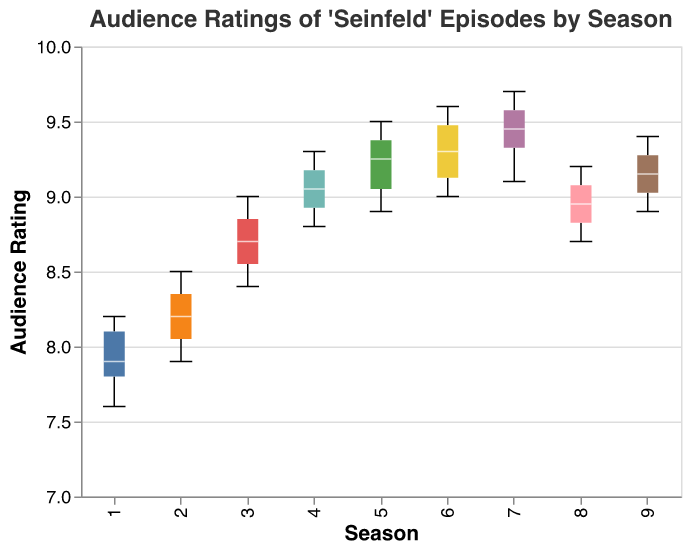What is the title of the plot? The title of the plot is located at the top of the figure and provides a summary of what the plot represents.
Answer: "Audience Ratings of 'Seinfeld' Episodes by Season" How many seasons of 'Seinfeld' are represented in the plot? Counting the distinct groups along the x-axis, we can see the different seasons represented.
Answer: 9 Which season has the highest median audience rating? The median can be identified by examining the line inside each box; the season with the highest median line is Season 7.
Answer: Season 7 What is the range of ratings for Season 1? The range can be determined by looking at the distance between the minimum and maximum ticks inside the box plot for Season 1. The range is from 7.6 to 8.2.
Answer: 0.6 Is there a season with no overlap in ratings with Season 7? By examining the notches in the box plot, which indicate the confidence intervals for the medians, we can see if there is any overlap. Season 1 does not overlap with Season 7.
Answer: Season 1 What is the median rating for Season 5? The median is marked by the line inside the box for Season 5, which is around 9.3.
Answer: 9.3 Which season has the widest interquartile range (IQR) for audience ratings? The IQR is the range between the first quartile (bottom of the box) and the third quartile (top of the box); the season with the largest box is Season 1.
Answer: Season 1 How do the median ratings of Seasons 3 and 8 compare? By looking at the median lines inside the boxes for Seasons 3 and 8, we can compare their heights. The median for Season 3 is higher than that for Season 8.
Answer: Season 3 has a higher median Which season has the most consistent ratings? Consistency in ratings can be inferred by looking at the size of the IQR; the season with the smallest IQR, indicating less variability, is Season 8.
Answer: Season 8 